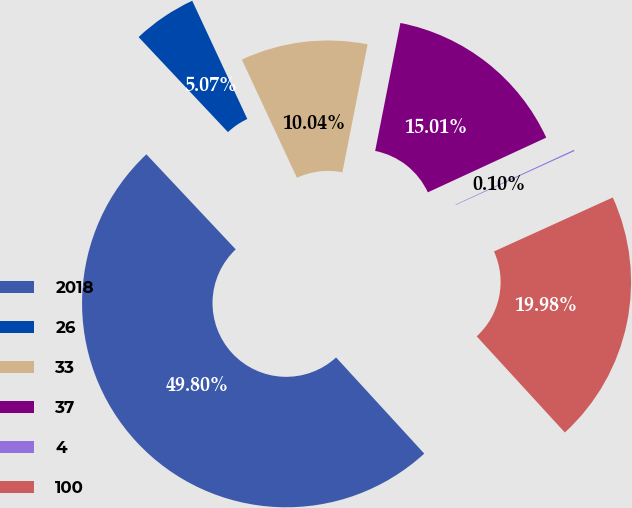Convert chart. <chart><loc_0><loc_0><loc_500><loc_500><pie_chart><fcel>2018<fcel>26<fcel>33<fcel>37<fcel>4<fcel>100<nl><fcel>49.8%<fcel>5.07%<fcel>10.04%<fcel>15.01%<fcel>0.1%<fcel>19.98%<nl></chart> 